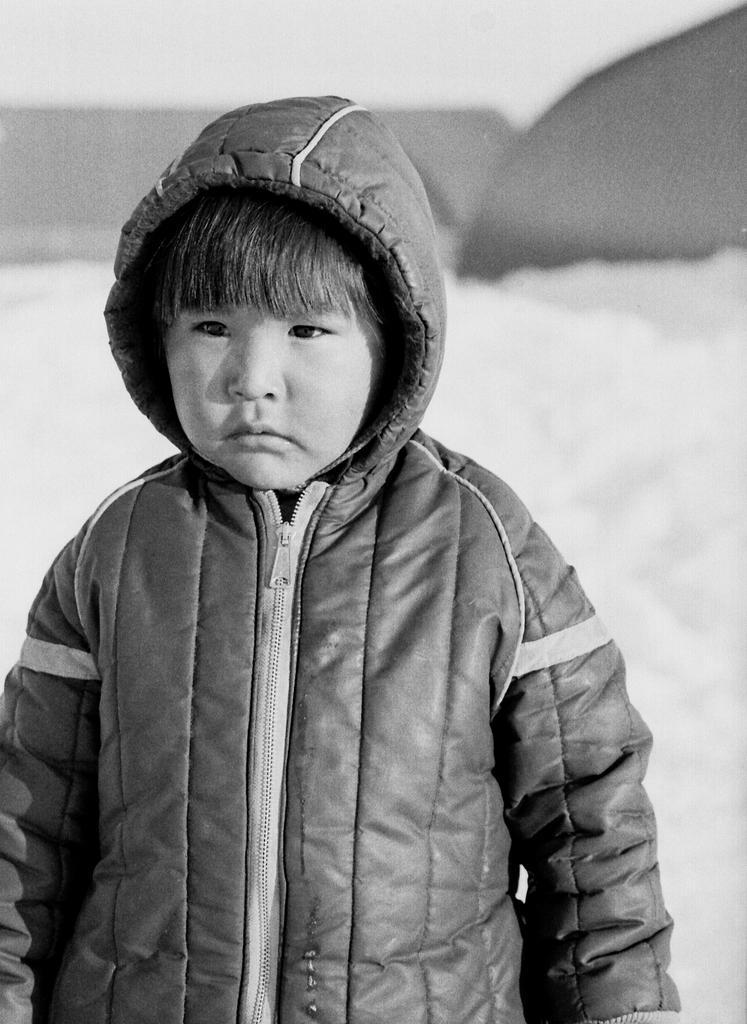Describe this image in one or two sentences. This picture seems to be clicked outside. In the foreground we can see a kid wearing a jacket and seems to be standing. In the background we can see the snow and some other objects and this picture seems to be the black and white image. 